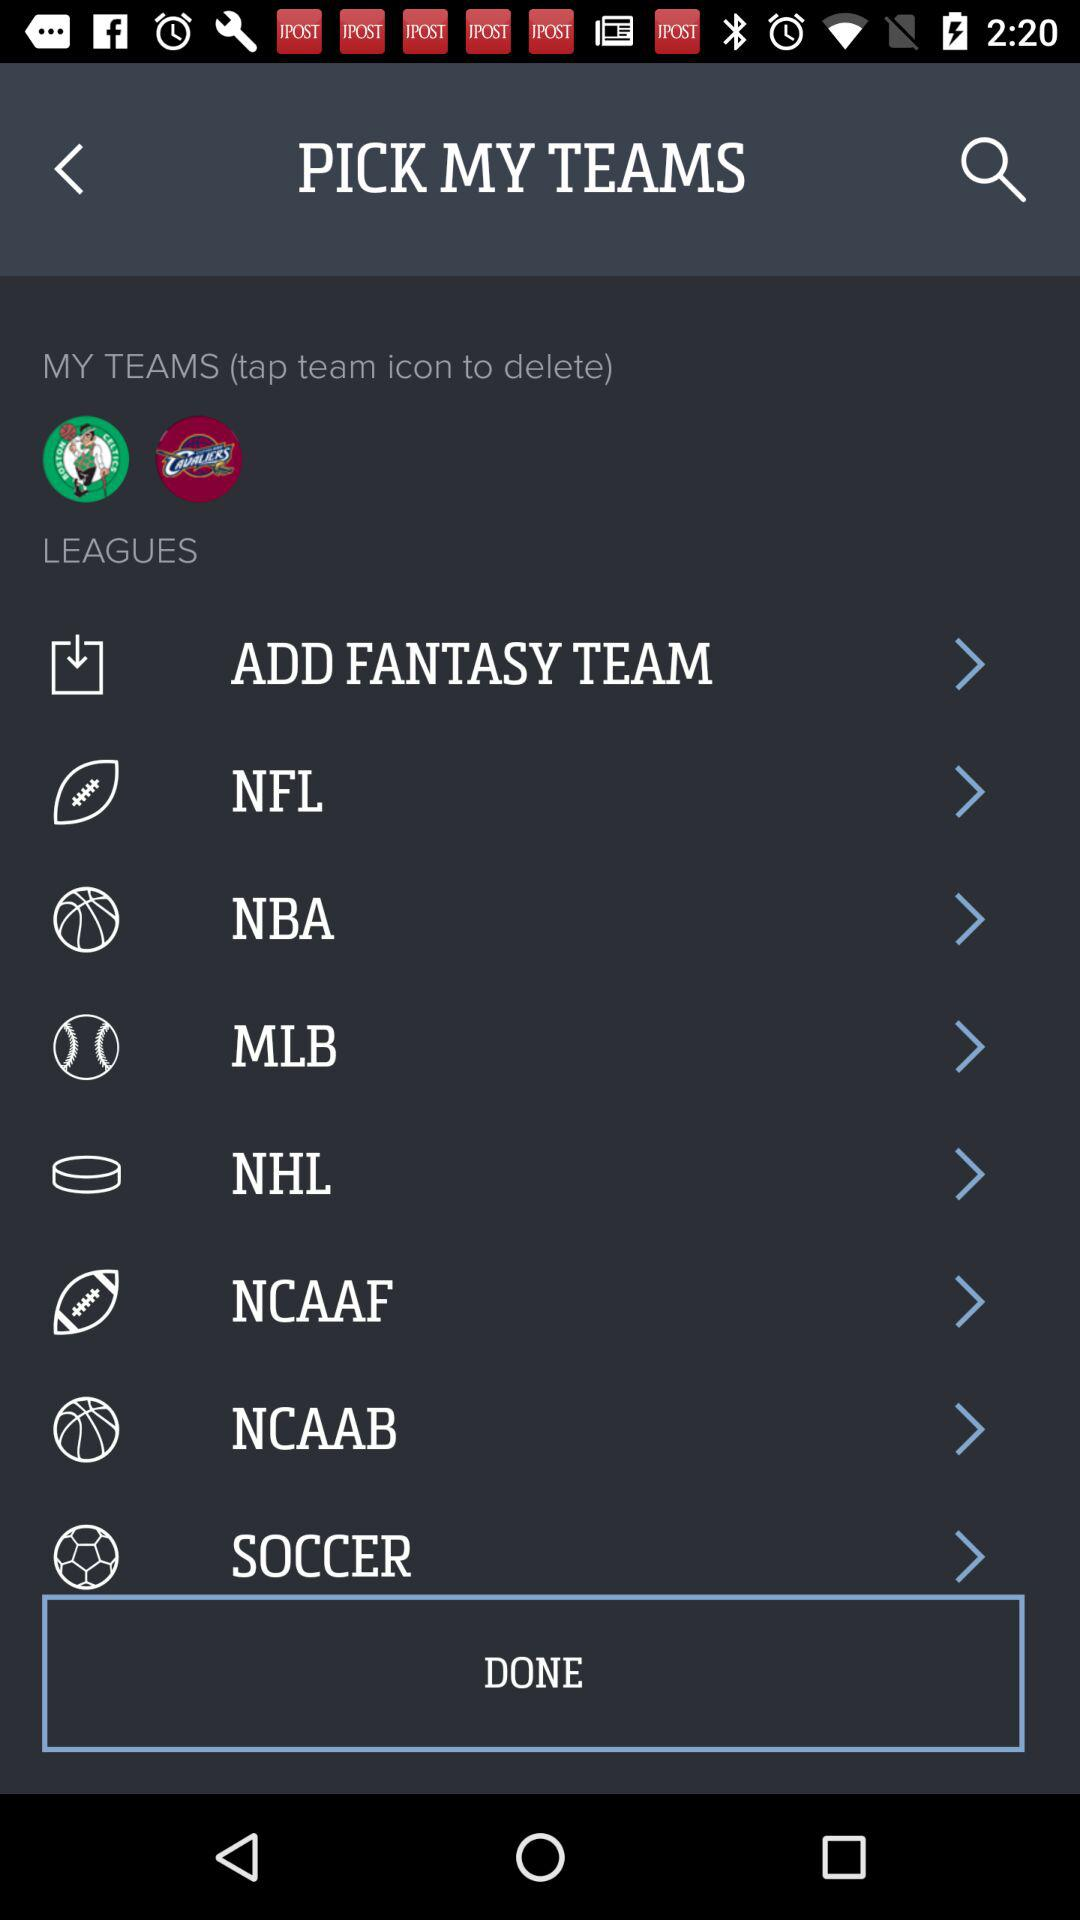List of teams available?
When the provided information is insufficient, respond with <no answer>. <no answer> 